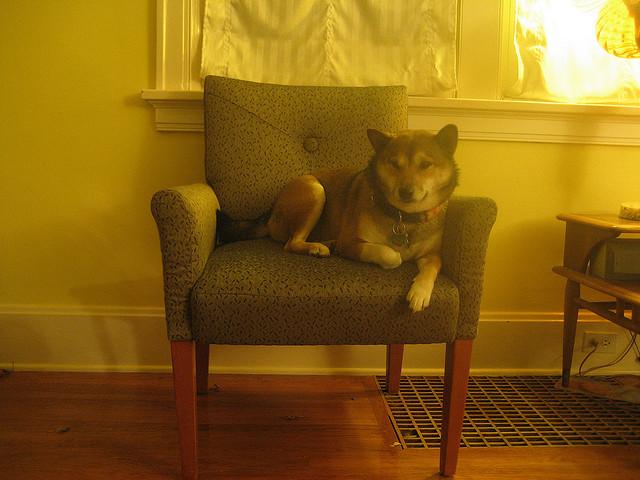Does the dog have a collar?
Keep it brief. Yes. What is the grate on the floor?
Be succinct. Air vent. Where is the dog?
Quick response, please. On chair. 